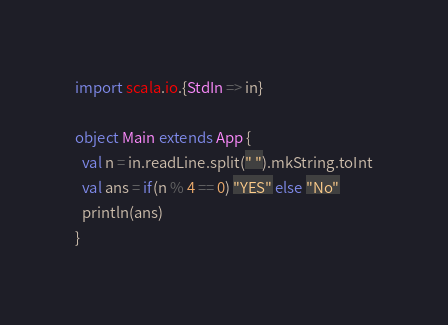Convert code to text. <code><loc_0><loc_0><loc_500><loc_500><_Scala_>import scala.io.{StdIn => in}

object Main extends App {
  val n = in.readLine.split(" ").mkString.toInt
  val ans = if(n % 4 == 0) "YES" else "No"
  println(ans)
}</code> 